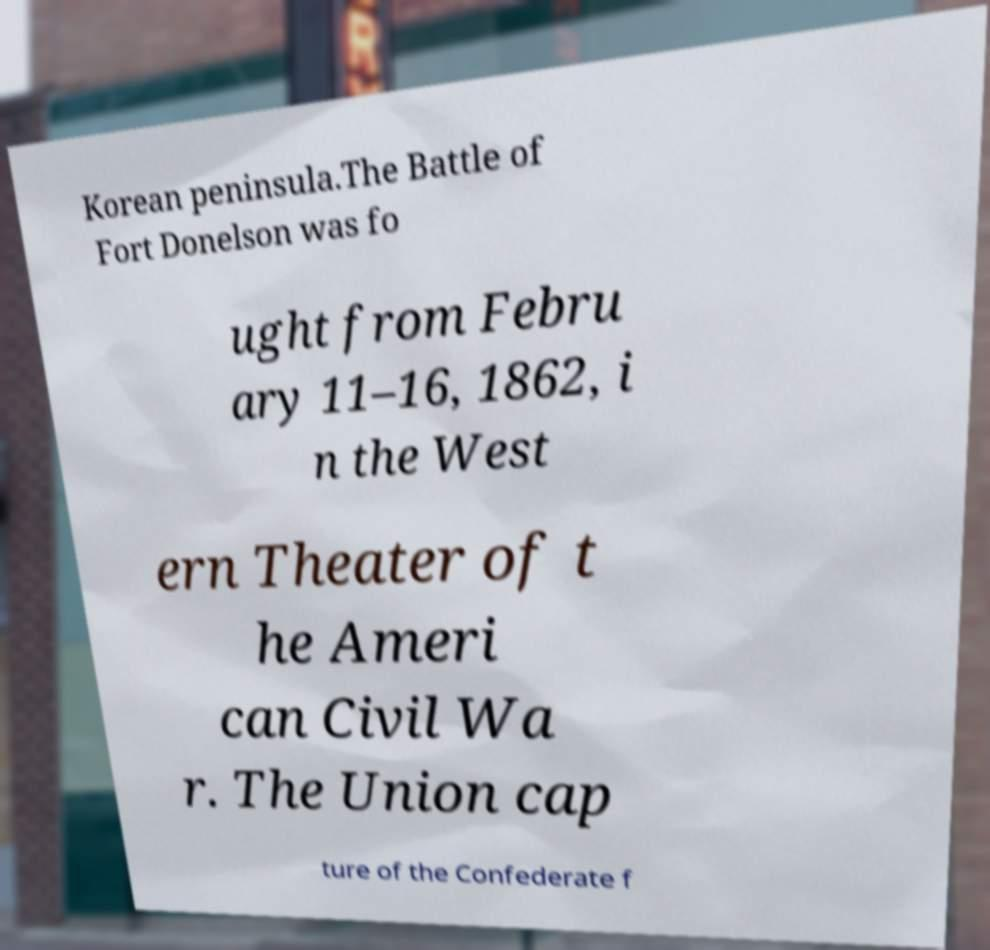Please read and relay the text visible in this image. What does it say? Korean peninsula.The Battle of Fort Donelson was fo ught from Febru ary 11–16, 1862, i n the West ern Theater of t he Ameri can Civil Wa r. The Union cap ture of the Confederate f 